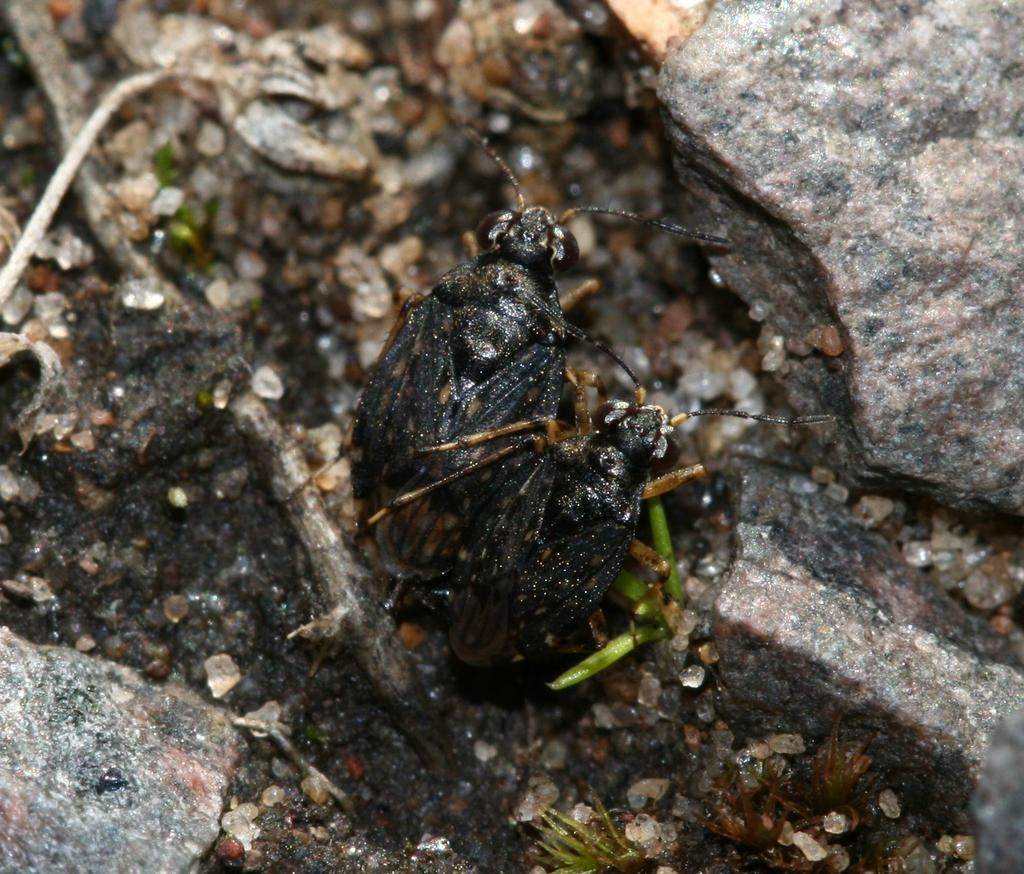What type of living organisms can be seen in the image? Insects can be seen in the image. What type of inanimate objects are visible in the image? Stones are visible in the image. What type of plough can be seen in the image? There is no plough present in the image. What type of earth can be seen in the image? There is no specific type of earth mentioned or visible in the image. 